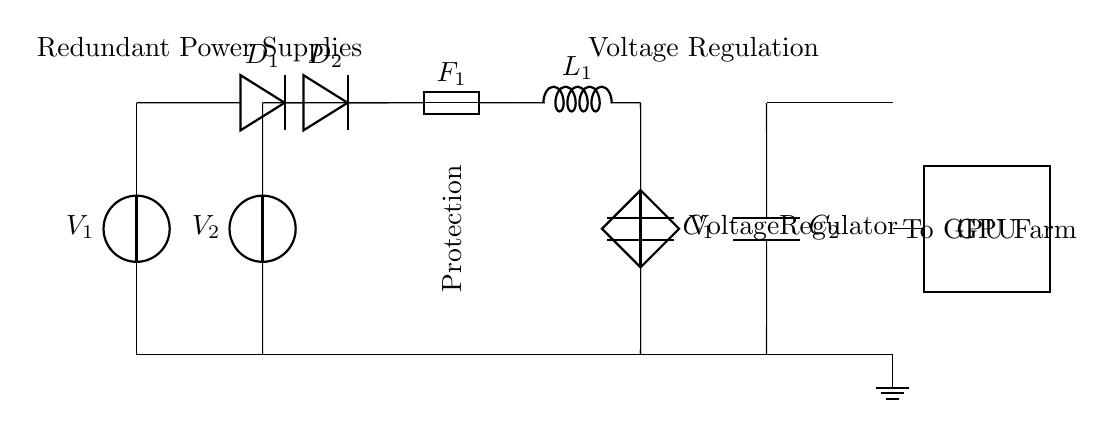What are the components used in the circuit? The circuit includes two voltage sources, two diodes, one fuse, one voltage regulator, two capacitors, and an inductor.
Answer: voltage sources, diodes, fuse, voltage regulator, capacitors, inductor How many power supplies are present in the circuit? There are two power supplies, labeled as V1 and V2.
Answer: two What is the function of the diodes in this circuit? The diodes (D1 and D2) are used for rectification and ensure that the current flows only in one direction, providing redundancy.
Answer: rectification Which component provides voltage regulation in the circuit? The voltage regulator is the component that regulates the output voltage to the GPU farm.
Answer: voltage regulator Explain how redundancy is achieved in this power supply circuit. Redundancy is achieved by having two separate power sources (V1 and V2) connected to diodes (D1 and D2), which allows either source to supply power independently, ensuring the system continues operating if one source fails.
Answer: two power supplies with diodes What role does the fuse play in this circuit? The fuse serves as a protection device that disconnects the circuit in case of an overload or short circuit, thus preventing damage to other components.
Answer: protection device How are the capacitors utilized in this circuit? The capacitors (C1 and C2) are used for filtering and stabilizing the output voltage, smoothing out any fluctuations before reaching the GPU.
Answer: filtering and stabilizing 